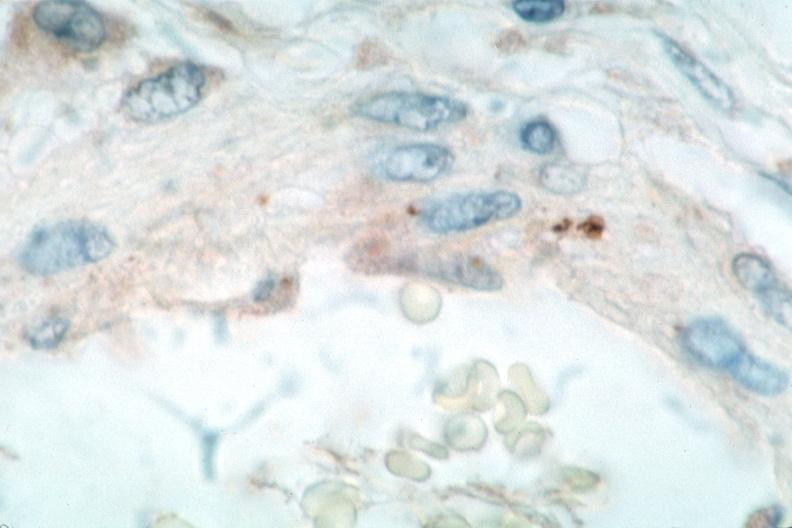s beckwith-wiedemann syndrome present?
Answer the question using a single word or phrase. No 